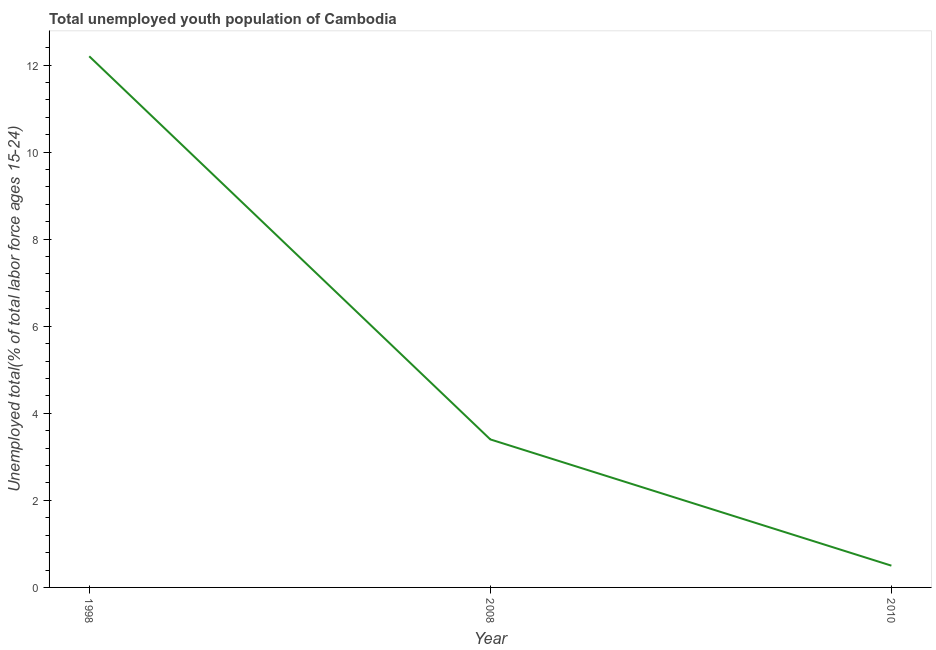What is the unemployed youth in 1998?
Make the answer very short. 12.2. Across all years, what is the maximum unemployed youth?
Ensure brevity in your answer.  12.2. Across all years, what is the minimum unemployed youth?
Offer a terse response. 0.5. In which year was the unemployed youth maximum?
Offer a terse response. 1998. In which year was the unemployed youth minimum?
Make the answer very short. 2010. What is the sum of the unemployed youth?
Your answer should be very brief. 16.1. What is the difference between the unemployed youth in 1998 and 2010?
Provide a short and direct response. 11.7. What is the average unemployed youth per year?
Provide a short and direct response. 5.37. What is the median unemployed youth?
Ensure brevity in your answer.  3.4. Do a majority of the years between 1998 and 2010 (inclusive) have unemployed youth greater than 0.4 %?
Offer a terse response. Yes. What is the ratio of the unemployed youth in 2008 to that in 2010?
Your answer should be compact. 6.8. Is the unemployed youth in 2008 less than that in 2010?
Give a very brief answer. No. What is the difference between the highest and the second highest unemployed youth?
Your response must be concise. 8.8. What is the difference between the highest and the lowest unemployed youth?
Offer a very short reply. 11.7. In how many years, is the unemployed youth greater than the average unemployed youth taken over all years?
Provide a succinct answer. 1. Does the unemployed youth monotonically increase over the years?
Provide a succinct answer. No. How many years are there in the graph?
Make the answer very short. 3. What is the title of the graph?
Your answer should be compact. Total unemployed youth population of Cambodia. What is the label or title of the X-axis?
Your answer should be compact. Year. What is the label or title of the Y-axis?
Make the answer very short. Unemployed total(% of total labor force ages 15-24). What is the Unemployed total(% of total labor force ages 15-24) of 1998?
Give a very brief answer. 12.2. What is the Unemployed total(% of total labor force ages 15-24) of 2008?
Offer a terse response. 3.4. What is the Unemployed total(% of total labor force ages 15-24) of 2010?
Provide a short and direct response. 0.5. What is the difference between the Unemployed total(% of total labor force ages 15-24) in 1998 and 2008?
Make the answer very short. 8.8. What is the difference between the Unemployed total(% of total labor force ages 15-24) in 1998 and 2010?
Offer a very short reply. 11.7. What is the difference between the Unemployed total(% of total labor force ages 15-24) in 2008 and 2010?
Your answer should be very brief. 2.9. What is the ratio of the Unemployed total(% of total labor force ages 15-24) in 1998 to that in 2008?
Make the answer very short. 3.59. What is the ratio of the Unemployed total(% of total labor force ages 15-24) in 1998 to that in 2010?
Keep it short and to the point. 24.4. What is the ratio of the Unemployed total(% of total labor force ages 15-24) in 2008 to that in 2010?
Offer a terse response. 6.8. 